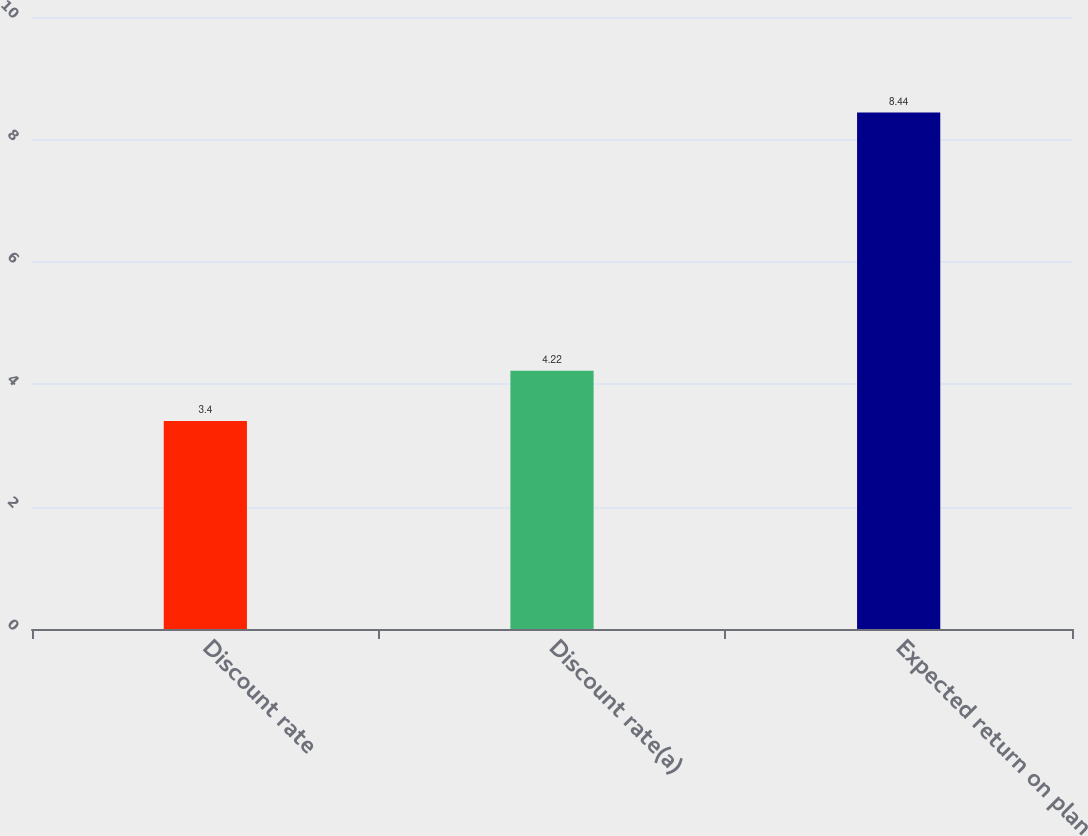Convert chart. <chart><loc_0><loc_0><loc_500><loc_500><bar_chart><fcel>Discount rate<fcel>Discount rate(a)<fcel>Expected return on plan<nl><fcel>3.4<fcel>4.22<fcel>8.44<nl></chart> 